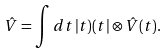Convert formula to latex. <formula><loc_0><loc_0><loc_500><loc_500>\hat { V } = \int d t \, | t ) ( t | \otimes \hat { V } ( t ) .</formula> 